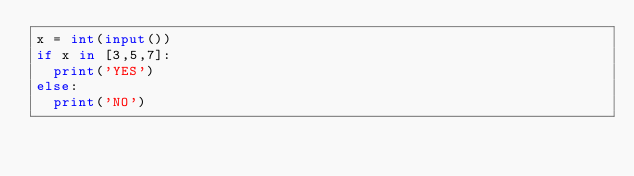<code> <loc_0><loc_0><loc_500><loc_500><_Python_>x = int(input())
if x in [3,5,7]:
  print('YES')
else:
  print('NO')</code> 